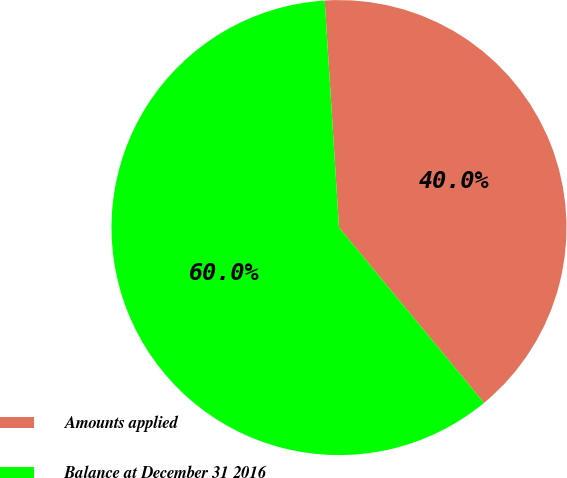Convert chart to OTSL. <chart><loc_0><loc_0><loc_500><loc_500><pie_chart><fcel>Amounts applied<fcel>Balance at December 31 2016<nl><fcel>40.0%<fcel>60.0%<nl></chart> 